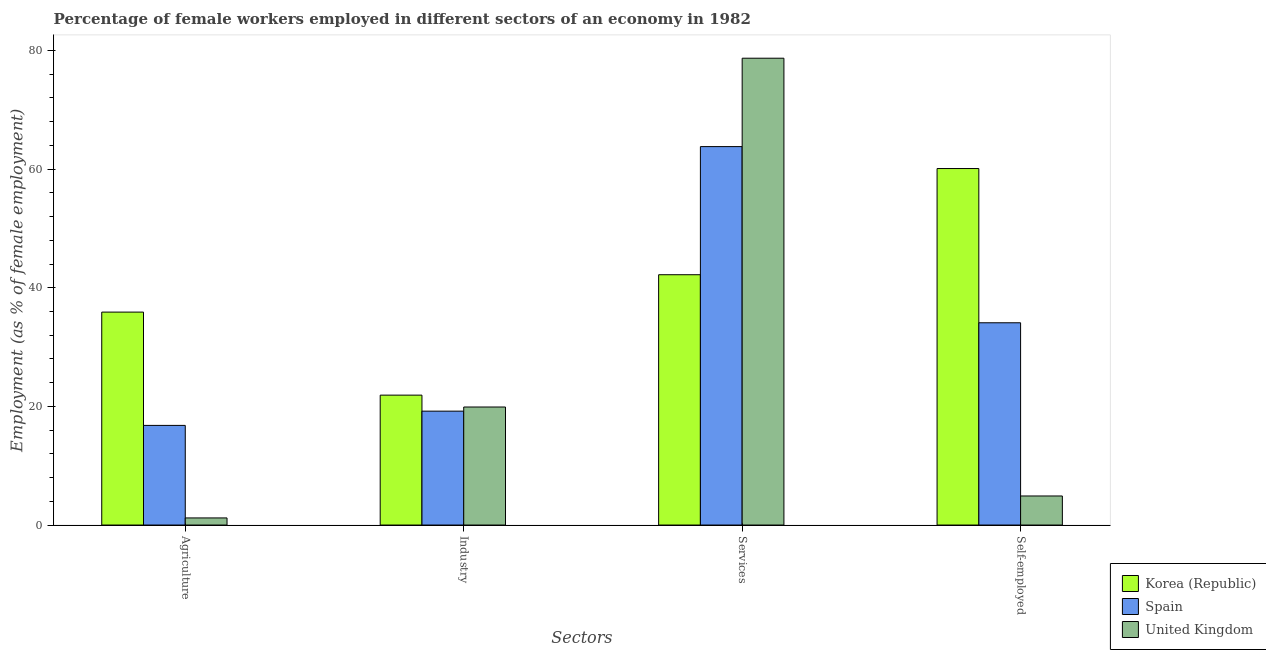Are the number of bars on each tick of the X-axis equal?
Offer a terse response. Yes. How many bars are there on the 1st tick from the left?
Keep it short and to the point. 3. How many bars are there on the 1st tick from the right?
Provide a succinct answer. 3. What is the label of the 2nd group of bars from the left?
Ensure brevity in your answer.  Industry. What is the percentage of female workers in industry in United Kingdom?
Your response must be concise. 19.9. Across all countries, what is the maximum percentage of female workers in services?
Your answer should be compact. 78.7. Across all countries, what is the minimum percentage of female workers in services?
Give a very brief answer. 42.2. In which country was the percentage of female workers in industry maximum?
Keep it short and to the point. Korea (Republic). What is the total percentage of female workers in industry in the graph?
Your answer should be compact. 61. What is the difference between the percentage of self employed female workers in Korea (Republic) and that in United Kingdom?
Provide a short and direct response. 55.2. What is the difference between the percentage of female workers in agriculture in Korea (Republic) and the percentage of self employed female workers in Spain?
Make the answer very short. 1.8. What is the average percentage of self employed female workers per country?
Your response must be concise. 33.03. What is the difference between the percentage of female workers in agriculture and percentage of female workers in services in Korea (Republic)?
Offer a terse response. -6.3. In how many countries, is the percentage of female workers in agriculture greater than 68 %?
Your answer should be very brief. 0. What is the ratio of the percentage of female workers in agriculture in Spain to that in United Kingdom?
Give a very brief answer. 14. Is the percentage of self employed female workers in Spain less than that in Korea (Republic)?
Offer a very short reply. Yes. Is the difference between the percentage of female workers in services in Korea (Republic) and Spain greater than the difference between the percentage of female workers in industry in Korea (Republic) and Spain?
Your answer should be compact. No. What is the difference between the highest and the second highest percentage of female workers in agriculture?
Offer a terse response. 19.1. What is the difference between the highest and the lowest percentage of female workers in agriculture?
Your response must be concise. 34.7. Is the sum of the percentage of female workers in industry in Korea (Republic) and United Kingdom greater than the maximum percentage of self employed female workers across all countries?
Your answer should be very brief. No. What does the 2nd bar from the left in Industry represents?
Offer a terse response. Spain. What is the difference between two consecutive major ticks on the Y-axis?
Ensure brevity in your answer.  20. Are the values on the major ticks of Y-axis written in scientific E-notation?
Give a very brief answer. No. Does the graph contain any zero values?
Provide a short and direct response. No. How many legend labels are there?
Offer a very short reply. 3. What is the title of the graph?
Provide a short and direct response. Percentage of female workers employed in different sectors of an economy in 1982. What is the label or title of the X-axis?
Ensure brevity in your answer.  Sectors. What is the label or title of the Y-axis?
Give a very brief answer. Employment (as % of female employment). What is the Employment (as % of female employment) in Korea (Republic) in Agriculture?
Your answer should be compact. 35.9. What is the Employment (as % of female employment) in Spain in Agriculture?
Keep it short and to the point. 16.8. What is the Employment (as % of female employment) of United Kingdom in Agriculture?
Make the answer very short. 1.2. What is the Employment (as % of female employment) of Korea (Republic) in Industry?
Provide a short and direct response. 21.9. What is the Employment (as % of female employment) in Spain in Industry?
Ensure brevity in your answer.  19.2. What is the Employment (as % of female employment) of United Kingdom in Industry?
Make the answer very short. 19.9. What is the Employment (as % of female employment) in Korea (Republic) in Services?
Your response must be concise. 42.2. What is the Employment (as % of female employment) of Spain in Services?
Your answer should be compact. 63.8. What is the Employment (as % of female employment) in United Kingdom in Services?
Your response must be concise. 78.7. What is the Employment (as % of female employment) in Korea (Republic) in Self-employed?
Your answer should be compact. 60.1. What is the Employment (as % of female employment) in Spain in Self-employed?
Offer a terse response. 34.1. What is the Employment (as % of female employment) in United Kingdom in Self-employed?
Give a very brief answer. 4.9. Across all Sectors, what is the maximum Employment (as % of female employment) in Korea (Republic)?
Provide a short and direct response. 60.1. Across all Sectors, what is the maximum Employment (as % of female employment) in Spain?
Your answer should be compact. 63.8. Across all Sectors, what is the maximum Employment (as % of female employment) of United Kingdom?
Give a very brief answer. 78.7. Across all Sectors, what is the minimum Employment (as % of female employment) of Korea (Republic)?
Give a very brief answer. 21.9. Across all Sectors, what is the minimum Employment (as % of female employment) in Spain?
Keep it short and to the point. 16.8. Across all Sectors, what is the minimum Employment (as % of female employment) in United Kingdom?
Offer a terse response. 1.2. What is the total Employment (as % of female employment) of Korea (Republic) in the graph?
Give a very brief answer. 160.1. What is the total Employment (as % of female employment) in Spain in the graph?
Keep it short and to the point. 133.9. What is the total Employment (as % of female employment) in United Kingdom in the graph?
Your answer should be very brief. 104.7. What is the difference between the Employment (as % of female employment) of United Kingdom in Agriculture and that in Industry?
Make the answer very short. -18.7. What is the difference between the Employment (as % of female employment) of Spain in Agriculture and that in Services?
Give a very brief answer. -47. What is the difference between the Employment (as % of female employment) of United Kingdom in Agriculture and that in Services?
Provide a succinct answer. -77.5. What is the difference between the Employment (as % of female employment) in Korea (Republic) in Agriculture and that in Self-employed?
Your response must be concise. -24.2. What is the difference between the Employment (as % of female employment) of Spain in Agriculture and that in Self-employed?
Your answer should be very brief. -17.3. What is the difference between the Employment (as % of female employment) of United Kingdom in Agriculture and that in Self-employed?
Offer a very short reply. -3.7. What is the difference between the Employment (as % of female employment) of Korea (Republic) in Industry and that in Services?
Your answer should be compact. -20.3. What is the difference between the Employment (as % of female employment) of Spain in Industry and that in Services?
Offer a terse response. -44.6. What is the difference between the Employment (as % of female employment) in United Kingdom in Industry and that in Services?
Offer a terse response. -58.8. What is the difference between the Employment (as % of female employment) in Korea (Republic) in Industry and that in Self-employed?
Ensure brevity in your answer.  -38.2. What is the difference between the Employment (as % of female employment) in Spain in Industry and that in Self-employed?
Make the answer very short. -14.9. What is the difference between the Employment (as % of female employment) in Korea (Republic) in Services and that in Self-employed?
Offer a terse response. -17.9. What is the difference between the Employment (as % of female employment) of Spain in Services and that in Self-employed?
Provide a short and direct response. 29.7. What is the difference between the Employment (as % of female employment) in United Kingdom in Services and that in Self-employed?
Make the answer very short. 73.8. What is the difference between the Employment (as % of female employment) in Korea (Republic) in Agriculture and the Employment (as % of female employment) in United Kingdom in Industry?
Your response must be concise. 16. What is the difference between the Employment (as % of female employment) of Korea (Republic) in Agriculture and the Employment (as % of female employment) of Spain in Services?
Give a very brief answer. -27.9. What is the difference between the Employment (as % of female employment) of Korea (Republic) in Agriculture and the Employment (as % of female employment) of United Kingdom in Services?
Offer a terse response. -42.8. What is the difference between the Employment (as % of female employment) in Spain in Agriculture and the Employment (as % of female employment) in United Kingdom in Services?
Your answer should be compact. -61.9. What is the difference between the Employment (as % of female employment) of Korea (Republic) in Agriculture and the Employment (as % of female employment) of Spain in Self-employed?
Give a very brief answer. 1.8. What is the difference between the Employment (as % of female employment) in Korea (Republic) in Agriculture and the Employment (as % of female employment) in United Kingdom in Self-employed?
Give a very brief answer. 31. What is the difference between the Employment (as % of female employment) in Korea (Republic) in Industry and the Employment (as % of female employment) in Spain in Services?
Your answer should be compact. -41.9. What is the difference between the Employment (as % of female employment) in Korea (Republic) in Industry and the Employment (as % of female employment) in United Kingdom in Services?
Provide a succinct answer. -56.8. What is the difference between the Employment (as % of female employment) in Spain in Industry and the Employment (as % of female employment) in United Kingdom in Services?
Your answer should be very brief. -59.5. What is the difference between the Employment (as % of female employment) in Korea (Republic) in Industry and the Employment (as % of female employment) in United Kingdom in Self-employed?
Provide a succinct answer. 17. What is the difference between the Employment (as % of female employment) in Spain in Industry and the Employment (as % of female employment) in United Kingdom in Self-employed?
Your answer should be compact. 14.3. What is the difference between the Employment (as % of female employment) in Korea (Republic) in Services and the Employment (as % of female employment) in Spain in Self-employed?
Ensure brevity in your answer.  8.1. What is the difference between the Employment (as % of female employment) of Korea (Republic) in Services and the Employment (as % of female employment) of United Kingdom in Self-employed?
Make the answer very short. 37.3. What is the difference between the Employment (as % of female employment) in Spain in Services and the Employment (as % of female employment) in United Kingdom in Self-employed?
Your response must be concise. 58.9. What is the average Employment (as % of female employment) in Korea (Republic) per Sectors?
Give a very brief answer. 40.02. What is the average Employment (as % of female employment) of Spain per Sectors?
Your response must be concise. 33.48. What is the average Employment (as % of female employment) of United Kingdom per Sectors?
Provide a short and direct response. 26.18. What is the difference between the Employment (as % of female employment) of Korea (Republic) and Employment (as % of female employment) of Spain in Agriculture?
Make the answer very short. 19.1. What is the difference between the Employment (as % of female employment) in Korea (Republic) and Employment (as % of female employment) in United Kingdom in Agriculture?
Ensure brevity in your answer.  34.7. What is the difference between the Employment (as % of female employment) of Spain and Employment (as % of female employment) of United Kingdom in Agriculture?
Ensure brevity in your answer.  15.6. What is the difference between the Employment (as % of female employment) in Korea (Republic) and Employment (as % of female employment) in Spain in Industry?
Keep it short and to the point. 2.7. What is the difference between the Employment (as % of female employment) of Spain and Employment (as % of female employment) of United Kingdom in Industry?
Keep it short and to the point. -0.7. What is the difference between the Employment (as % of female employment) in Korea (Republic) and Employment (as % of female employment) in Spain in Services?
Provide a succinct answer. -21.6. What is the difference between the Employment (as % of female employment) in Korea (Republic) and Employment (as % of female employment) in United Kingdom in Services?
Make the answer very short. -36.5. What is the difference between the Employment (as % of female employment) in Spain and Employment (as % of female employment) in United Kingdom in Services?
Your response must be concise. -14.9. What is the difference between the Employment (as % of female employment) of Korea (Republic) and Employment (as % of female employment) of United Kingdom in Self-employed?
Your answer should be compact. 55.2. What is the difference between the Employment (as % of female employment) in Spain and Employment (as % of female employment) in United Kingdom in Self-employed?
Offer a terse response. 29.2. What is the ratio of the Employment (as % of female employment) of Korea (Republic) in Agriculture to that in Industry?
Offer a very short reply. 1.64. What is the ratio of the Employment (as % of female employment) of United Kingdom in Agriculture to that in Industry?
Keep it short and to the point. 0.06. What is the ratio of the Employment (as % of female employment) of Korea (Republic) in Agriculture to that in Services?
Make the answer very short. 0.85. What is the ratio of the Employment (as % of female employment) of Spain in Agriculture to that in Services?
Provide a short and direct response. 0.26. What is the ratio of the Employment (as % of female employment) in United Kingdom in Agriculture to that in Services?
Your answer should be compact. 0.02. What is the ratio of the Employment (as % of female employment) of Korea (Republic) in Agriculture to that in Self-employed?
Offer a very short reply. 0.6. What is the ratio of the Employment (as % of female employment) of Spain in Agriculture to that in Self-employed?
Provide a short and direct response. 0.49. What is the ratio of the Employment (as % of female employment) of United Kingdom in Agriculture to that in Self-employed?
Give a very brief answer. 0.24. What is the ratio of the Employment (as % of female employment) in Korea (Republic) in Industry to that in Services?
Provide a succinct answer. 0.52. What is the ratio of the Employment (as % of female employment) of Spain in Industry to that in Services?
Make the answer very short. 0.3. What is the ratio of the Employment (as % of female employment) of United Kingdom in Industry to that in Services?
Ensure brevity in your answer.  0.25. What is the ratio of the Employment (as % of female employment) of Korea (Republic) in Industry to that in Self-employed?
Offer a very short reply. 0.36. What is the ratio of the Employment (as % of female employment) in Spain in Industry to that in Self-employed?
Your answer should be compact. 0.56. What is the ratio of the Employment (as % of female employment) of United Kingdom in Industry to that in Self-employed?
Your response must be concise. 4.06. What is the ratio of the Employment (as % of female employment) of Korea (Republic) in Services to that in Self-employed?
Keep it short and to the point. 0.7. What is the ratio of the Employment (as % of female employment) in Spain in Services to that in Self-employed?
Offer a terse response. 1.87. What is the ratio of the Employment (as % of female employment) of United Kingdom in Services to that in Self-employed?
Give a very brief answer. 16.06. What is the difference between the highest and the second highest Employment (as % of female employment) in Spain?
Ensure brevity in your answer.  29.7. What is the difference between the highest and the second highest Employment (as % of female employment) in United Kingdom?
Keep it short and to the point. 58.8. What is the difference between the highest and the lowest Employment (as % of female employment) in Korea (Republic)?
Your response must be concise. 38.2. What is the difference between the highest and the lowest Employment (as % of female employment) in United Kingdom?
Offer a terse response. 77.5. 